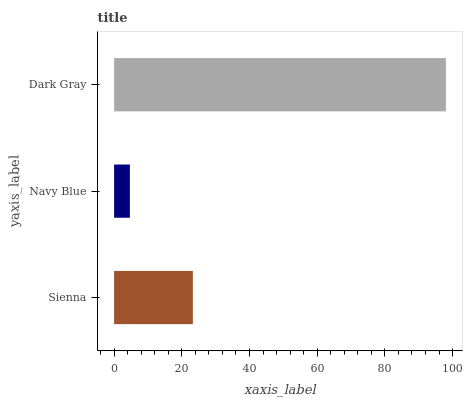Is Navy Blue the minimum?
Answer yes or no. Yes. Is Dark Gray the maximum?
Answer yes or no. Yes. Is Dark Gray the minimum?
Answer yes or no. No. Is Navy Blue the maximum?
Answer yes or no. No. Is Dark Gray greater than Navy Blue?
Answer yes or no. Yes. Is Navy Blue less than Dark Gray?
Answer yes or no. Yes. Is Navy Blue greater than Dark Gray?
Answer yes or no. No. Is Dark Gray less than Navy Blue?
Answer yes or no. No. Is Sienna the high median?
Answer yes or no. Yes. Is Sienna the low median?
Answer yes or no. Yes. Is Navy Blue the high median?
Answer yes or no. No. Is Dark Gray the low median?
Answer yes or no. No. 